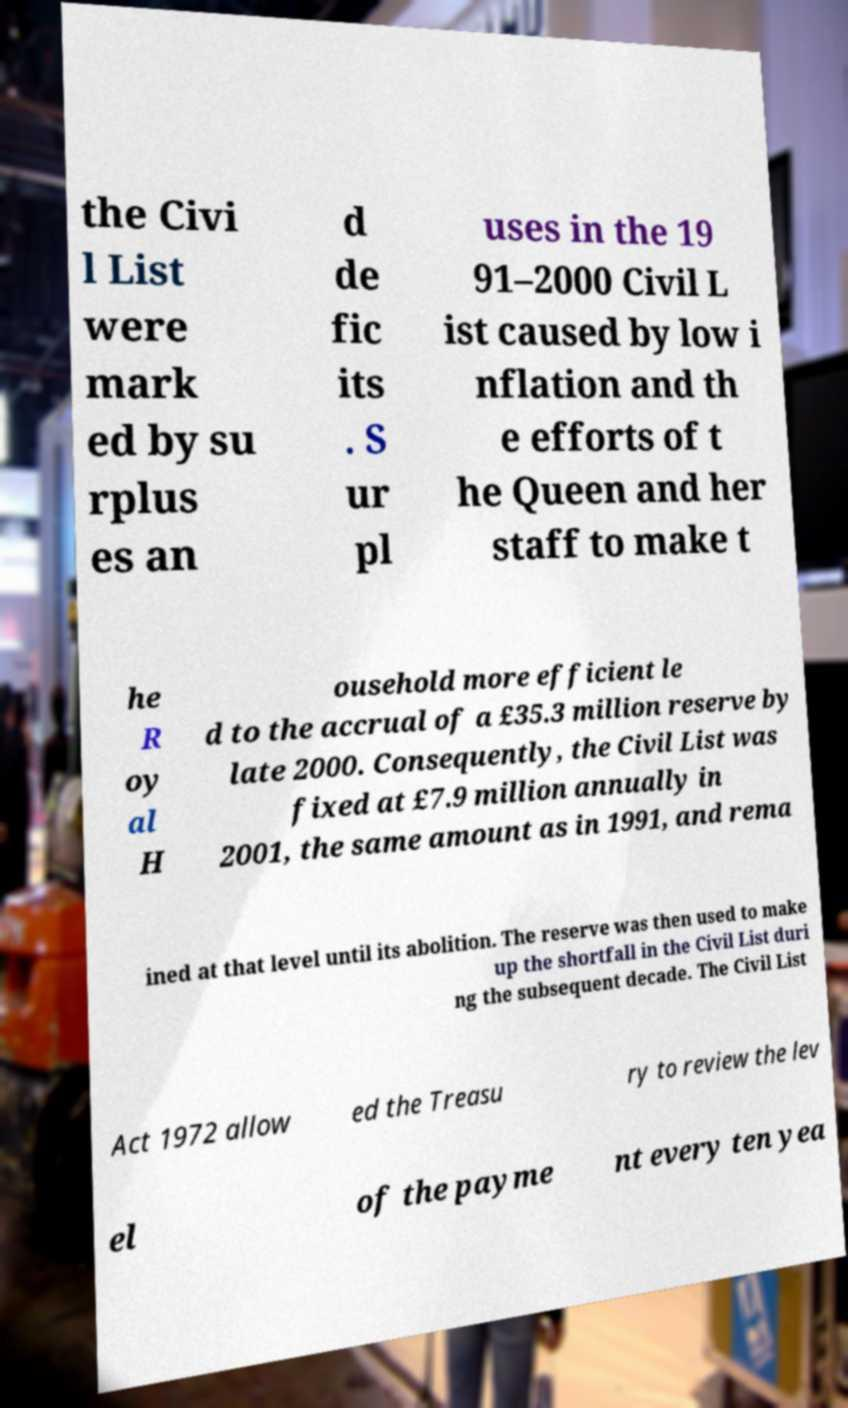There's text embedded in this image that I need extracted. Can you transcribe it verbatim? the Civi l List were mark ed by su rplus es an d de fic its . S ur pl uses in the 19 91–2000 Civil L ist caused by low i nflation and th e efforts of t he Queen and her staff to make t he R oy al H ousehold more efficient le d to the accrual of a £35.3 million reserve by late 2000. Consequently, the Civil List was fixed at £7.9 million annually in 2001, the same amount as in 1991, and rema ined at that level until its abolition. The reserve was then used to make up the shortfall in the Civil List duri ng the subsequent decade. The Civil List Act 1972 allow ed the Treasu ry to review the lev el of the payme nt every ten yea 